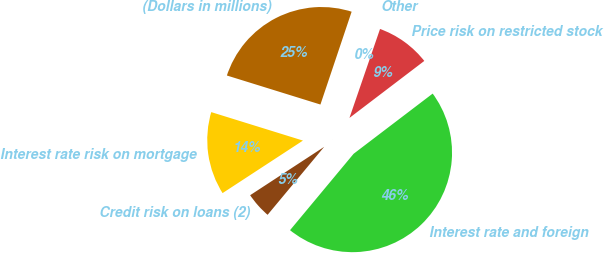Convert chart. <chart><loc_0><loc_0><loc_500><loc_500><pie_chart><fcel>(Dollars in millions)<fcel>Interest rate risk on mortgage<fcel>Credit risk on loans (2)<fcel>Interest rate and foreign<fcel>Price risk on restricted stock<fcel>Other<nl><fcel>25.37%<fcel>14.0%<fcel>4.74%<fcel>46.4%<fcel>9.37%<fcel>0.11%<nl></chart> 